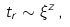Convert formula to latex. <formula><loc_0><loc_0><loc_500><loc_500>t _ { r } \sim \xi ^ { z } \, ,</formula> 